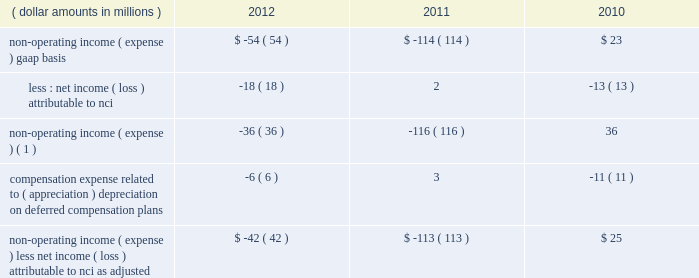The portion of compensation expense associated with certain long-term incentive plans ( 201cltip 201d ) funded or to be funded through share distributions to participants of blackrock stock held by pnc and a merrill lynch & co. , inc .
( 201cmerrill lynch 201d ) cash compensation contribution , has been excluded because it ultimately does not impact blackrock 2019s book value .
The expense related to the merrill lynch cash compensation contribution ceased at the end of third quarter 2011 .
As of first quarter 2012 , all of the merrill lynch contributions had been received .
Compensation expense associated with appreciation ( depreciation ) on investments related to certain blackrock deferred compensation plans has been excluded as returns on investments set aside for these plans , which substantially offset this expense , are reported in non-operating income ( expense ) .
Management believes operating income exclusive of these items is a useful measure in evaluating blackrock 2019s operating performance and helps enhance the comparability of this information for the reporting periods presented .
Operating margin , as adjusted : operating income used for measuring operating margin , as adjusted , is equal to operating income , as adjusted , excluding the impact of closed-end fund launch costs and commissions .
Management believes the exclusion of such costs and commissions is useful because these costs can fluctuate considerably and revenues associated with the expenditure of these costs will not fully impact the company 2019s results until future periods .
Operating margin , as adjusted , allows the company to compare performance from period-to-period by adjusting for items that may not recur , recur infrequently or may have an economic offset in non-operating income ( expense ) .
Examples of such adjustments include bgi transaction and integration costs , u.k .
Lease exit costs , contribution to stifs , restructuring charges , closed-end fund launch costs , commissions paid to certain employees as compensation and fluctuations in compensation expense based on mark-to-market movements in investments held to fund certain compensation plans .
The company also uses operating margin , as adjusted , to monitor corporate performance and efficiency and as a benchmark to compare its performance with other companies .
Management uses both the gaap and non- gaap financial measures in evaluating the financial performance of blackrock .
The non-gaap measure by itself may pose limitations because it does not include all of the company 2019s revenues and expenses .
Revenue used for operating margin , as adjusted , excludes distribution and servicing costs paid to related parties and other third parties .
Management believes the exclusion of such costs is useful because it creates consistency in the treatment for certain contracts for similar services , which due to the terms of the contracts , are accounted for under gaap on a net basis within investment advisory , administration fees and securities lending revenue .
Amortization of deferred sales commissions is excluded from revenue used for operating margin measurement , as adjusted , because such costs , over time , substantially offset distribution fee revenue earned by the company .
For each of these items , blackrock excludes from revenue used for operating margin , as adjusted , the costs related to each of these items as a proxy for such offsetting revenues .
( b ) non-operating income ( expense ) , less net income ( loss ) attributable to non-controlling interests , as adjusted : non-operating income ( expense ) , less net income ( loss ) attributable to nci , as adjusted , is presented below .
The compensation expense offset is recorded in operating income .
This compensation expense has been included in non-operating income ( expense ) , less net income ( loss ) attributable to nci , as adjusted , to offset returns on investments set aside for these plans , which are reported in non-operating income ( expense ) , gaap basis .
( dollar amounts in millions ) 2012 2011 2010 non-operating income ( expense ) , gaap basis .
$ ( 54 ) $ ( 114 ) $ 23 less : net income ( loss ) attributable to nci .
( 18 ) 2 ( 13 ) non-operating income ( expense ) ( 1 ) .
( 36 ) ( 116 ) 36 compensation expense related to ( appreciation ) depreciation on deferred compensation plans .
( 6 ) 3 ( 11 ) non-operating income ( expense ) , less net income ( loss ) attributable to nci , as adjusted .
$ ( 42 ) $ ( 113 ) $ 25 ( 1 ) net of net income ( loss ) attributable to nci .
Management believes non-operating income ( expense ) , less net income ( loss ) attributable to nci , as adjusted , provides comparability of this information among reporting periods and is an effective measure for reviewing blackrock 2019s non-operating contribution to its results .
As compensation expense associated with ( appreciation ) depreciation on investments related to certain deferred compensation plans , which is included in operating income , substantially offsets the gain ( loss ) on the investments set aside for these plans , management .
The portion of compensation expense associated with certain long-term incentive plans ( 201cltip 201d ) funded or to be funded through share distributions to participants of blackrock stock held by pnc and a merrill lynch & co. , inc .
( 201cmerrill lynch 201d ) cash compensation contribution , has been excluded because it ultimately does not impact blackrock 2019s book value .
The expense related to the merrill lynch cash compensation contribution ceased at the end of third quarter 2011 .
As of first quarter 2012 , all of the merrill lynch contributions had been received .
Compensation expense associated with appreciation ( depreciation ) on investments related to certain blackrock deferred compensation plans has been excluded as returns on investments set aside for these plans , which substantially offset this expense , are reported in non-operating income ( expense ) .
Management believes operating income exclusive of these items is a useful measure in evaluating blackrock 2019s operating performance and helps enhance the comparability of this information for the reporting periods presented .
Operating margin , as adjusted : operating income used for measuring operating margin , as adjusted , is equal to operating income , as adjusted , excluding the impact of closed-end fund launch costs and commissions .
Management believes the exclusion of such costs and commissions is useful because these costs can fluctuate considerably and revenues associated with the expenditure of these costs will not fully impact the company 2019s results until future periods .
Operating margin , as adjusted , allows the company to compare performance from period-to-period by adjusting for items that may not recur , recur infrequently or may have an economic offset in non-operating income ( expense ) .
Examples of such adjustments include bgi transaction and integration costs , u.k .
Lease exit costs , contribution to stifs , restructuring charges , closed-end fund launch costs , commissions paid to certain employees as compensation and fluctuations in compensation expense based on mark-to-market movements in investments held to fund certain compensation plans .
The company also uses operating margin , as adjusted , to monitor corporate performance and efficiency and as a benchmark to compare its performance with other companies .
Management uses both the gaap and non- gaap financial measures in evaluating the financial performance of blackrock .
The non-gaap measure by itself may pose limitations because it does not include all of the company 2019s revenues and expenses .
Revenue used for operating margin , as adjusted , excludes distribution and servicing costs paid to related parties and other third parties .
Management believes the exclusion of such costs is useful because it creates consistency in the treatment for certain contracts for similar services , which due to the terms of the contracts , are accounted for under gaap on a net basis within investment advisory , administration fees and securities lending revenue .
Amortization of deferred sales commissions is excluded from revenue used for operating margin measurement , as adjusted , because such costs , over time , substantially offset distribution fee revenue earned by the company .
For each of these items , blackrock excludes from revenue used for operating margin , as adjusted , the costs related to each of these items as a proxy for such offsetting revenues .
( b ) non-operating income ( expense ) , less net income ( loss ) attributable to non-controlling interests , as adjusted : non-operating income ( expense ) , less net income ( loss ) attributable to nci , as adjusted , is presented below .
The compensation expense offset is recorded in operating income .
This compensation expense has been included in non-operating income ( expense ) , less net income ( loss ) attributable to nci , as adjusted , to offset returns on investments set aside for these plans , which are reported in non-operating income ( expense ) , gaap basis .
( dollar amounts in millions ) 2012 2011 2010 non-operating income ( expense ) , gaap basis .
$ ( 54 ) $ ( 114 ) $ 23 less : net income ( loss ) attributable to nci .
( 18 ) 2 ( 13 ) non-operating income ( expense ) ( 1 ) .
( 36 ) ( 116 ) 36 compensation expense related to ( appreciation ) depreciation on deferred compensation plans .
( 6 ) 3 ( 11 ) non-operating income ( expense ) , less net income ( loss ) attributable to nci , as adjusted .
$ ( 42 ) $ ( 113 ) $ 25 ( 1 ) net of net income ( loss ) attributable to nci .
Management believes non-operating income ( expense ) , less net income ( loss ) attributable to nci , as adjusted , provides comparability of this information among reporting periods and is an effective measure for reviewing blackrock 2019s non-operating contribution to its results .
As compensation expense associated with ( appreciation ) depreciation on investments related to certain deferred compensation plans , which is included in operating income , substantially offsets the gain ( loss ) on the investments set aside for these plans , management .
What is the net change in non-operating income from 2010 to 2011? 
Computations: (-116 - 36)
Answer: -152.0. 